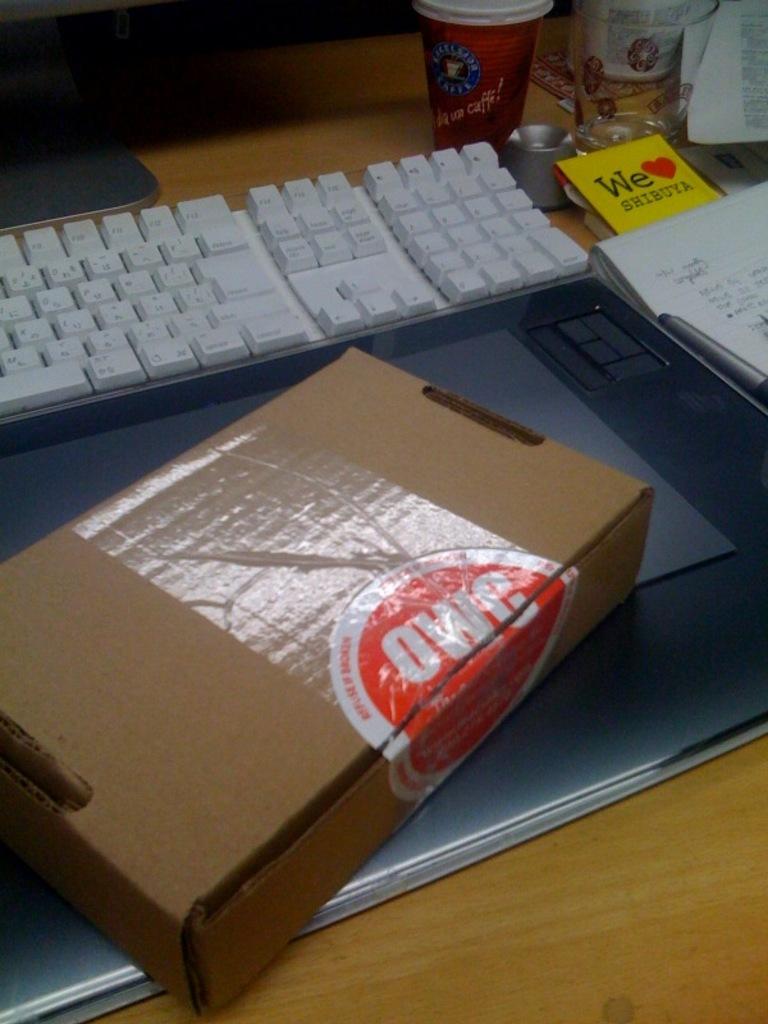What does the little yellow paper say?
Ensure brevity in your answer.  We love shibuya. 